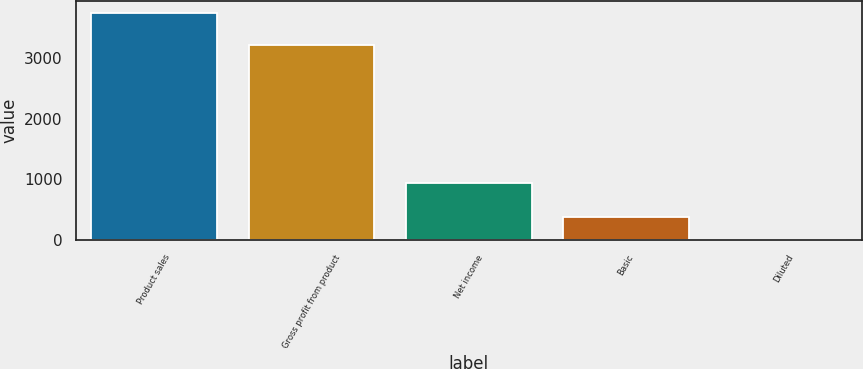Convert chart to OTSL. <chart><loc_0><loc_0><loc_500><loc_500><bar_chart><fcel>Product sales<fcel>Gross profit from product<fcel>Net income<fcel>Basic<fcel>Diluted<nl><fcel>3743<fcel>3205<fcel>931<fcel>375.13<fcel>0.92<nl></chart> 